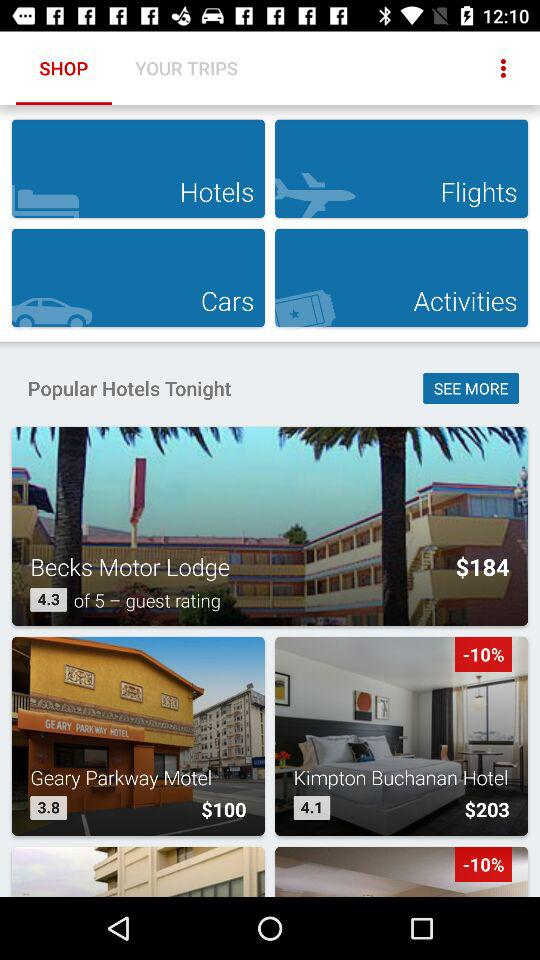Which tab is selected? The selected tab is "SHOP". 